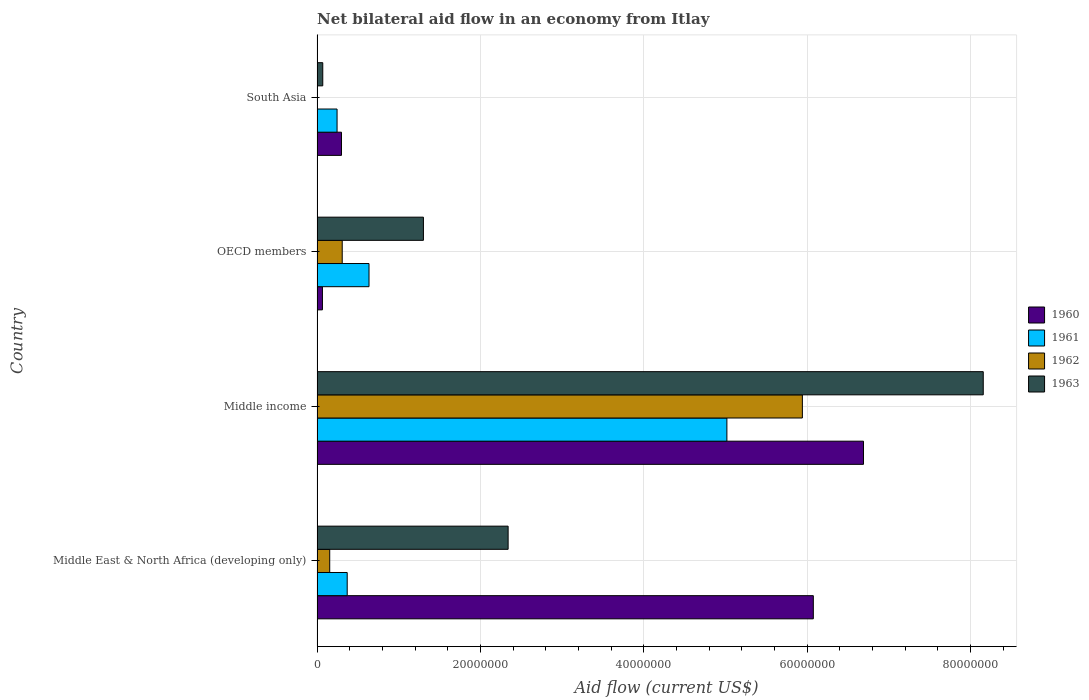How many different coloured bars are there?
Give a very brief answer. 4. Are the number of bars on each tick of the Y-axis equal?
Keep it short and to the point. No. How many bars are there on the 3rd tick from the top?
Your answer should be very brief. 4. In how many cases, is the number of bars for a given country not equal to the number of legend labels?
Give a very brief answer. 1. What is the net bilateral aid flow in 1963 in Middle East & North Africa (developing only)?
Provide a succinct answer. 2.34e+07. Across all countries, what is the maximum net bilateral aid flow in 1960?
Your response must be concise. 6.69e+07. Across all countries, what is the minimum net bilateral aid flow in 1962?
Keep it short and to the point. 0. In which country was the net bilateral aid flow in 1960 maximum?
Provide a short and direct response. Middle income. What is the total net bilateral aid flow in 1960 in the graph?
Keep it short and to the point. 1.31e+08. What is the difference between the net bilateral aid flow in 1960 in OECD members and that in South Asia?
Offer a terse response. -2.33e+06. What is the difference between the net bilateral aid flow in 1960 in Middle income and the net bilateral aid flow in 1963 in Middle East & North Africa (developing only)?
Make the answer very short. 4.35e+07. What is the average net bilateral aid flow in 1960 per country?
Make the answer very short. 3.28e+07. What is the difference between the net bilateral aid flow in 1963 and net bilateral aid flow in 1961 in South Asia?
Your answer should be compact. -1.75e+06. In how many countries, is the net bilateral aid flow in 1961 greater than 8000000 US$?
Offer a very short reply. 1. What is the ratio of the net bilateral aid flow in 1963 in Middle East & North Africa (developing only) to that in OECD members?
Offer a terse response. 1.8. What is the difference between the highest and the second highest net bilateral aid flow in 1963?
Your answer should be compact. 5.82e+07. What is the difference between the highest and the lowest net bilateral aid flow in 1961?
Give a very brief answer. 4.77e+07. Is it the case that in every country, the sum of the net bilateral aid flow in 1961 and net bilateral aid flow in 1960 is greater than the sum of net bilateral aid flow in 1963 and net bilateral aid flow in 1962?
Ensure brevity in your answer.  No. How many bars are there?
Offer a terse response. 15. Are all the bars in the graph horizontal?
Your answer should be very brief. Yes. What is the difference between two consecutive major ticks on the X-axis?
Provide a succinct answer. 2.00e+07. Are the values on the major ticks of X-axis written in scientific E-notation?
Give a very brief answer. No. What is the title of the graph?
Your answer should be very brief. Net bilateral aid flow in an economy from Itlay. Does "1970" appear as one of the legend labels in the graph?
Make the answer very short. No. What is the label or title of the Y-axis?
Make the answer very short. Country. What is the Aid flow (current US$) of 1960 in Middle East & North Africa (developing only)?
Your answer should be compact. 6.08e+07. What is the Aid flow (current US$) of 1961 in Middle East & North Africa (developing only)?
Make the answer very short. 3.69e+06. What is the Aid flow (current US$) of 1962 in Middle East & North Africa (developing only)?
Your response must be concise. 1.55e+06. What is the Aid flow (current US$) of 1963 in Middle East & North Africa (developing only)?
Keep it short and to the point. 2.34e+07. What is the Aid flow (current US$) of 1960 in Middle income?
Provide a succinct answer. 6.69e+07. What is the Aid flow (current US$) of 1961 in Middle income?
Provide a succinct answer. 5.02e+07. What is the Aid flow (current US$) in 1962 in Middle income?
Ensure brevity in your answer.  5.94e+07. What is the Aid flow (current US$) of 1963 in Middle income?
Offer a terse response. 8.16e+07. What is the Aid flow (current US$) of 1960 in OECD members?
Ensure brevity in your answer.  6.60e+05. What is the Aid flow (current US$) in 1961 in OECD members?
Your answer should be very brief. 6.36e+06. What is the Aid flow (current US$) of 1962 in OECD members?
Your answer should be compact. 3.08e+06. What is the Aid flow (current US$) in 1963 in OECD members?
Keep it short and to the point. 1.30e+07. What is the Aid flow (current US$) of 1960 in South Asia?
Your answer should be compact. 2.99e+06. What is the Aid flow (current US$) in 1961 in South Asia?
Your response must be concise. 2.45e+06. What is the Aid flow (current US$) in 1962 in South Asia?
Your answer should be compact. 0. Across all countries, what is the maximum Aid flow (current US$) in 1960?
Your answer should be very brief. 6.69e+07. Across all countries, what is the maximum Aid flow (current US$) in 1961?
Ensure brevity in your answer.  5.02e+07. Across all countries, what is the maximum Aid flow (current US$) in 1962?
Your answer should be compact. 5.94e+07. Across all countries, what is the maximum Aid flow (current US$) in 1963?
Ensure brevity in your answer.  8.16e+07. Across all countries, what is the minimum Aid flow (current US$) in 1961?
Offer a terse response. 2.45e+06. Across all countries, what is the minimum Aid flow (current US$) of 1963?
Provide a short and direct response. 7.00e+05. What is the total Aid flow (current US$) in 1960 in the graph?
Ensure brevity in your answer.  1.31e+08. What is the total Aid flow (current US$) of 1961 in the graph?
Make the answer very short. 6.27e+07. What is the total Aid flow (current US$) of 1962 in the graph?
Give a very brief answer. 6.40e+07. What is the total Aid flow (current US$) in 1963 in the graph?
Provide a succinct answer. 1.19e+08. What is the difference between the Aid flow (current US$) in 1960 in Middle East & North Africa (developing only) and that in Middle income?
Keep it short and to the point. -6.14e+06. What is the difference between the Aid flow (current US$) of 1961 in Middle East & North Africa (developing only) and that in Middle income?
Provide a succinct answer. -4.65e+07. What is the difference between the Aid flow (current US$) of 1962 in Middle East & North Africa (developing only) and that in Middle income?
Your response must be concise. -5.79e+07. What is the difference between the Aid flow (current US$) of 1963 in Middle East & North Africa (developing only) and that in Middle income?
Provide a short and direct response. -5.82e+07. What is the difference between the Aid flow (current US$) of 1960 in Middle East & North Africa (developing only) and that in OECD members?
Your answer should be compact. 6.01e+07. What is the difference between the Aid flow (current US$) in 1961 in Middle East & North Africa (developing only) and that in OECD members?
Provide a succinct answer. -2.67e+06. What is the difference between the Aid flow (current US$) of 1962 in Middle East & North Africa (developing only) and that in OECD members?
Give a very brief answer. -1.53e+06. What is the difference between the Aid flow (current US$) of 1963 in Middle East & North Africa (developing only) and that in OECD members?
Give a very brief answer. 1.04e+07. What is the difference between the Aid flow (current US$) in 1960 in Middle East & North Africa (developing only) and that in South Asia?
Make the answer very short. 5.78e+07. What is the difference between the Aid flow (current US$) of 1961 in Middle East & North Africa (developing only) and that in South Asia?
Offer a very short reply. 1.24e+06. What is the difference between the Aid flow (current US$) of 1963 in Middle East & North Africa (developing only) and that in South Asia?
Your answer should be very brief. 2.27e+07. What is the difference between the Aid flow (current US$) in 1960 in Middle income and that in OECD members?
Offer a terse response. 6.62e+07. What is the difference between the Aid flow (current US$) in 1961 in Middle income and that in OECD members?
Provide a short and direct response. 4.38e+07. What is the difference between the Aid flow (current US$) of 1962 in Middle income and that in OECD members?
Provide a short and direct response. 5.63e+07. What is the difference between the Aid flow (current US$) in 1963 in Middle income and that in OECD members?
Offer a very short reply. 6.85e+07. What is the difference between the Aid flow (current US$) of 1960 in Middle income and that in South Asia?
Give a very brief answer. 6.39e+07. What is the difference between the Aid flow (current US$) in 1961 in Middle income and that in South Asia?
Make the answer very short. 4.77e+07. What is the difference between the Aid flow (current US$) in 1963 in Middle income and that in South Asia?
Your answer should be very brief. 8.08e+07. What is the difference between the Aid flow (current US$) of 1960 in OECD members and that in South Asia?
Your answer should be compact. -2.33e+06. What is the difference between the Aid flow (current US$) in 1961 in OECD members and that in South Asia?
Give a very brief answer. 3.91e+06. What is the difference between the Aid flow (current US$) of 1963 in OECD members and that in South Asia?
Offer a terse response. 1.23e+07. What is the difference between the Aid flow (current US$) in 1960 in Middle East & North Africa (developing only) and the Aid flow (current US$) in 1961 in Middle income?
Your answer should be compact. 1.06e+07. What is the difference between the Aid flow (current US$) of 1960 in Middle East & North Africa (developing only) and the Aid flow (current US$) of 1962 in Middle income?
Your answer should be very brief. 1.34e+06. What is the difference between the Aid flow (current US$) of 1960 in Middle East & North Africa (developing only) and the Aid flow (current US$) of 1963 in Middle income?
Your answer should be very brief. -2.08e+07. What is the difference between the Aid flow (current US$) of 1961 in Middle East & North Africa (developing only) and the Aid flow (current US$) of 1962 in Middle income?
Your answer should be very brief. -5.57e+07. What is the difference between the Aid flow (current US$) of 1961 in Middle East & North Africa (developing only) and the Aid flow (current US$) of 1963 in Middle income?
Offer a very short reply. -7.79e+07. What is the difference between the Aid flow (current US$) in 1962 in Middle East & North Africa (developing only) and the Aid flow (current US$) in 1963 in Middle income?
Your response must be concise. -8.00e+07. What is the difference between the Aid flow (current US$) in 1960 in Middle East & North Africa (developing only) and the Aid flow (current US$) in 1961 in OECD members?
Give a very brief answer. 5.44e+07. What is the difference between the Aid flow (current US$) in 1960 in Middle East & North Africa (developing only) and the Aid flow (current US$) in 1962 in OECD members?
Keep it short and to the point. 5.77e+07. What is the difference between the Aid flow (current US$) in 1960 in Middle East & North Africa (developing only) and the Aid flow (current US$) in 1963 in OECD members?
Make the answer very short. 4.77e+07. What is the difference between the Aid flow (current US$) of 1961 in Middle East & North Africa (developing only) and the Aid flow (current US$) of 1962 in OECD members?
Make the answer very short. 6.10e+05. What is the difference between the Aid flow (current US$) of 1961 in Middle East & North Africa (developing only) and the Aid flow (current US$) of 1963 in OECD members?
Provide a succinct answer. -9.33e+06. What is the difference between the Aid flow (current US$) in 1962 in Middle East & North Africa (developing only) and the Aid flow (current US$) in 1963 in OECD members?
Provide a short and direct response. -1.15e+07. What is the difference between the Aid flow (current US$) in 1960 in Middle East & North Africa (developing only) and the Aid flow (current US$) in 1961 in South Asia?
Provide a succinct answer. 5.83e+07. What is the difference between the Aid flow (current US$) in 1960 in Middle East & North Africa (developing only) and the Aid flow (current US$) in 1963 in South Asia?
Ensure brevity in your answer.  6.00e+07. What is the difference between the Aid flow (current US$) of 1961 in Middle East & North Africa (developing only) and the Aid flow (current US$) of 1963 in South Asia?
Your response must be concise. 2.99e+06. What is the difference between the Aid flow (current US$) in 1962 in Middle East & North Africa (developing only) and the Aid flow (current US$) in 1963 in South Asia?
Offer a very short reply. 8.50e+05. What is the difference between the Aid flow (current US$) in 1960 in Middle income and the Aid flow (current US$) in 1961 in OECD members?
Provide a succinct answer. 6.05e+07. What is the difference between the Aid flow (current US$) of 1960 in Middle income and the Aid flow (current US$) of 1962 in OECD members?
Keep it short and to the point. 6.38e+07. What is the difference between the Aid flow (current US$) of 1960 in Middle income and the Aid flow (current US$) of 1963 in OECD members?
Your answer should be very brief. 5.39e+07. What is the difference between the Aid flow (current US$) in 1961 in Middle income and the Aid flow (current US$) in 1962 in OECD members?
Your answer should be compact. 4.71e+07. What is the difference between the Aid flow (current US$) in 1961 in Middle income and the Aid flow (current US$) in 1963 in OECD members?
Your answer should be compact. 3.72e+07. What is the difference between the Aid flow (current US$) of 1962 in Middle income and the Aid flow (current US$) of 1963 in OECD members?
Offer a very short reply. 4.64e+07. What is the difference between the Aid flow (current US$) in 1960 in Middle income and the Aid flow (current US$) in 1961 in South Asia?
Offer a very short reply. 6.44e+07. What is the difference between the Aid flow (current US$) in 1960 in Middle income and the Aid flow (current US$) in 1963 in South Asia?
Your answer should be very brief. 6.62e+07. What is the difference between the Aid flow (current US$) of 1961 in Middle income and the Aid flow (current US$) of 1963 in South Asia?
Keep it short and to the point. 4.95e+07. What is the difference between the Aid flow (current US$) of 1962 in Middle income and the Aid flow (current US$) of 1963 in South Asia?
Provide a short and direct response. 5.87e+07. What is the difference between the Aid flow (current US$) in 1960 in OECD members and the Aid flow (current US$) in 1961 in South Asia?
Give a very brief answer. -1.79e+06. What is the difference between the Aid flow (current US$) of 1961 in OECD members and the Aid flow (current US$) of 1963 in South Asia?
Your response must be concise. 5.66e+06. What is the difference between the Aid flow (current US$) of 1962 in OECD members and the Aid flow (current US$) of 1963 in South Asia?
Your answer should be compact. 2.38e+06. What is the average Aid flow (current US$) of 1960 per country?
Give a very brief answer. 3.28e+07. What is the average Aid flow (current US$) of 1961 per country?
Ensure brevity in your answer.  1.57e+07. What is the average Aid flow (current US$) in 1962 per country?
Your answer should be compact. 1.60e+07. What is the average Aid flow (current US$) in 1963 per country?
Ensure brevity in your answer.  2.97e+07. What is the difference between the Aid flow (current US$) in 1960 and Aid flow (current US$) in 1961 in Middle East & North Africa (developing only)?
Keep it short and to the point. 5.71e+07. What is the difference between the Aid flow (current US$) of 1960 and Aid flow (current US$) of 1962 in Middle East & North Africa (developing only)?
Offer a very short reply. 5.92e+07. What is the difference between the Aid flow (current US$) in 1960 and Aid flow (current US$) in 1963 in Middle East & North Africa (developing only)?
Your answer should be compact. 3.74e+07. What is the difference between the Aid flow (current US$) of 1961 and Aid flow (current US$) of 1962 in Middle East & North Africa (developing only)?
Provide a succinct answer. 2.14e+06. What is the difference between the Aid flow (current US$) in 1961 and Aid flow (current US$) in 1963 in Middle East & North Africa (developing only)?
Provide a short and direct response. -1.97e+07. What is the difference between the Aid flow (current US$) in 1962 and Aid flow (current US$) in 1963 in Middle East & North Africa (developing only)?
Provide a short and direct response. -2.18e+07. What is the difference between the Aid flow (current US$) of 1960 and Aid flow (current US$) of 1961 in Middle income?
Offer a terse response. 1.67e+07. What is the difference between the Aid flow (current US$) of 1960 and Aid flow (current US$) of 1962 in Middle income?
Keep it short and to the point. 7.48e+06. What is the difference between the Aid flow (current US$) of 1960 and Aid flow (current US$) of 1963 in Middle income?
Your response must be concise. -1.47e+07. What is the difference between the Aid flow (current US$) of 1961 and Aid flow (current US$) of 1962 in Middle income?
Make the answer very short. -9.24e+06. What is the difference between the Aid flow (current US$) of 1961 and Aid flow (current US$) of 1963 in Middle income?
Your response must be concise. -3.14e+07. What is the difference between the Aid flow (current US$) in 1962 and Aid flow (current US$) in 1963 in Middle income?
Provide a succinct answer. -2.21e+07. What is the difference between the Aid flow (current US$) of 1960 and Aid flow (current US$) of 1961 in OECD members?
Make the answer very short. -5.70e+06. What is the difference between the Aid flow (current US$) in 1960 and Aid flow (current US$) in 1962 in OECD members?
Your answer should be very brief. -2.42e+06. What is the difference between the Aid flow (current US$) of 1960 and Aid flow (current US$) of 1963 in OECD members?
Your answer should be very brief. -1.24e+07. What is the difference between the Aid flow (current US$) of 1961 and Aid flow (current US$) of 1962 in OECD members?
Your answer should be very brief. 3.28e+06. What is the difference between the Aid flow (current US$) in 1961 and Aid flow (current US$) in 1963 in OECD members?
Keep it short and to the point. -6.66e+06. What is the difference between the Aid flow (current US$) in 1962 and Aid flow (current US$) in 1963 in OECD members?
Make the answer very short. -9.94e+06. What is the difference between the Aid flow (current US$) of 1960 and Aid flow (current US$) of 1961 in South Asia?
Your response must be concise. 5.40e+05. What is the difference between the Aid flow (current US$) in 1960 and Aid flow (current US$) in 1963 in South Asia?
Offer a very short reply. 2.29e+06. What is the difference between the Aid flow (current US$) in 1961 and Aid flow (current US$) in 1963 in South Asia?
Keep it short and to the point. 1.75e+06. What is the ratio of the Aid flow (current US$) in 1960 in Middle East & North Africa (developing only) to that in Middle income?
Keep it short and to the point. 0.91. What is the ratio of the Aid flow (current US$) in 1961 in Middle East & North Africa (developing only) to that in Middle income?
Make the answer very short. 0.07. What is the ratio of the Aid flow (current US$) in 1962 in Middle East & North Africa (developing only) to that in Middle income?
Offer a terse response. 0.03. What is the ratio of the Aid flow (current US$) in 1963 in Middle East & North Africa (developing only) to that in Middle income?
Your answer should be very brief. 0.29. What is the ratio of the Aid flow (current US$) of 1960 in Middle East & North Africa (developing only) to that in OECD members?
Your answer should be very brief. 92.05. What is the ratio of the Aid flow (current US$) in 1961 in Middle East & North Africa (developing only) to that in OECD members?
Give a very brief answer. 0.58. What is the ratio of the Aid flow (current US$) in 1962 in Middle East & North Africa (developing only) to that in OECD members?
Ensure brevity in your answer.  0.5. What is the ratio of the Aid flow (current US$) in 1963 in Middle East & North Africa (developing only) to that in OECD members?
Your answer should be compact. 1.8. What is the ratio of the Aid flow (current US$) of 1960 in Middle East & North Africa (developing only) to that in South Asia?
Your answer should be very brief. 20.32. What is the ratio of the Aid flow (current US$) of 1961 in Middle East & North Africa (developing only) to that in South Asia?
Give a very brief answer. 1.51. What is the ratio of the Aid flow (current US$) of 1963 in Middle East & North Africa (developing only) to that in South Asia?
Provide a succinct answer. 33.41. What is the ratio of the Aid flow (current US$) of 1960 in Middle income to that in OECD members?
Offer a very short reply. 101.35. What is the ratio of the Aid flow (current US$) of 1961 in Middle income to that in OECD members?
Your answer should be compact. 7.89. What is the ratio of the Aid flow (current US$) in 1962 in Middle income to that in OECD members?
Provide a short and direct response. 19.29. What is the ratio of the Aid flow (current US$) of 1963 in Middle income to that in OECD members?
Provide a succinct answer. 6.26. What is the ratio of the Aid flow (current US$) of 1960 in Middle income to that in South Asia?
Your answer should be compact. 22.37. What is the ratio of the Aid flow (current US$) of 1961 in Middle income to that in South Asia?
Give a very brief answer. 20.48. What is the ratio of the Aid flow (current US$) of 1963 in Middle income to that in South Asia?
Give a very brief answer. 116.5. What is the ratio of the Aid flow (current US$) in 1960 in OECD members to that in South Asia?
Provide a succinct answer. 0.22. What is the ratio of the Aid flow (current US$) in 1961 in OECD members to that in South Asia?
Make the answer very short. 2.6. What is the difference between the highest and the second highest Aid flow (current US$) of 1960?
Your answer should be very brief. 6.14e+06. What is the difference between the highest and the second highest Aid flow (current US$) in 1961?
Your answer should be very brief. 4.38e+07. What is the difference between the highest and the second highest Aid flow (current US$) in 1962?
Offer a very short reply. 5.63e+07. What is the difference between the highest and the second highest Aid flow (current US$) of 1963?
Provide a succinct answer. 5.82e+07. What is the difference between the highest and the lowest Aid flow (current US$) in 1960?
Offer a terse response. 6.62e+07. What is the difference between the highest and the lowest Aid flow (current US$) in 1961?
Make the answer very short. 4.77e+07. What is the difference between the highest and the lowest Aid flow (current US$) of 1962?
Make the answer very short. 5.94e+07. What is the difference between the highest and the lowest Aid flow (current US$) in 1963?
Offer a terse response. 8.08e+07. 